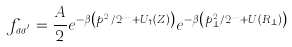<formula> <loc_0><loc_0><loc_500><loc_500>f _ { \sigma \sigma ^ { ^ { \prime } } } = \frac { A } { 2 } e ^ { - \beta \left ( { p _ { Z } ^ { 2 } } / { 2 m } + U _ { \uparrow } ( Z ) \right ) } e ^ { - \beta \left ( { p _ { \perp } ^ { 2 } } / { 2 m } + U ( R _ { \perp } ) \right ) }</formula> 